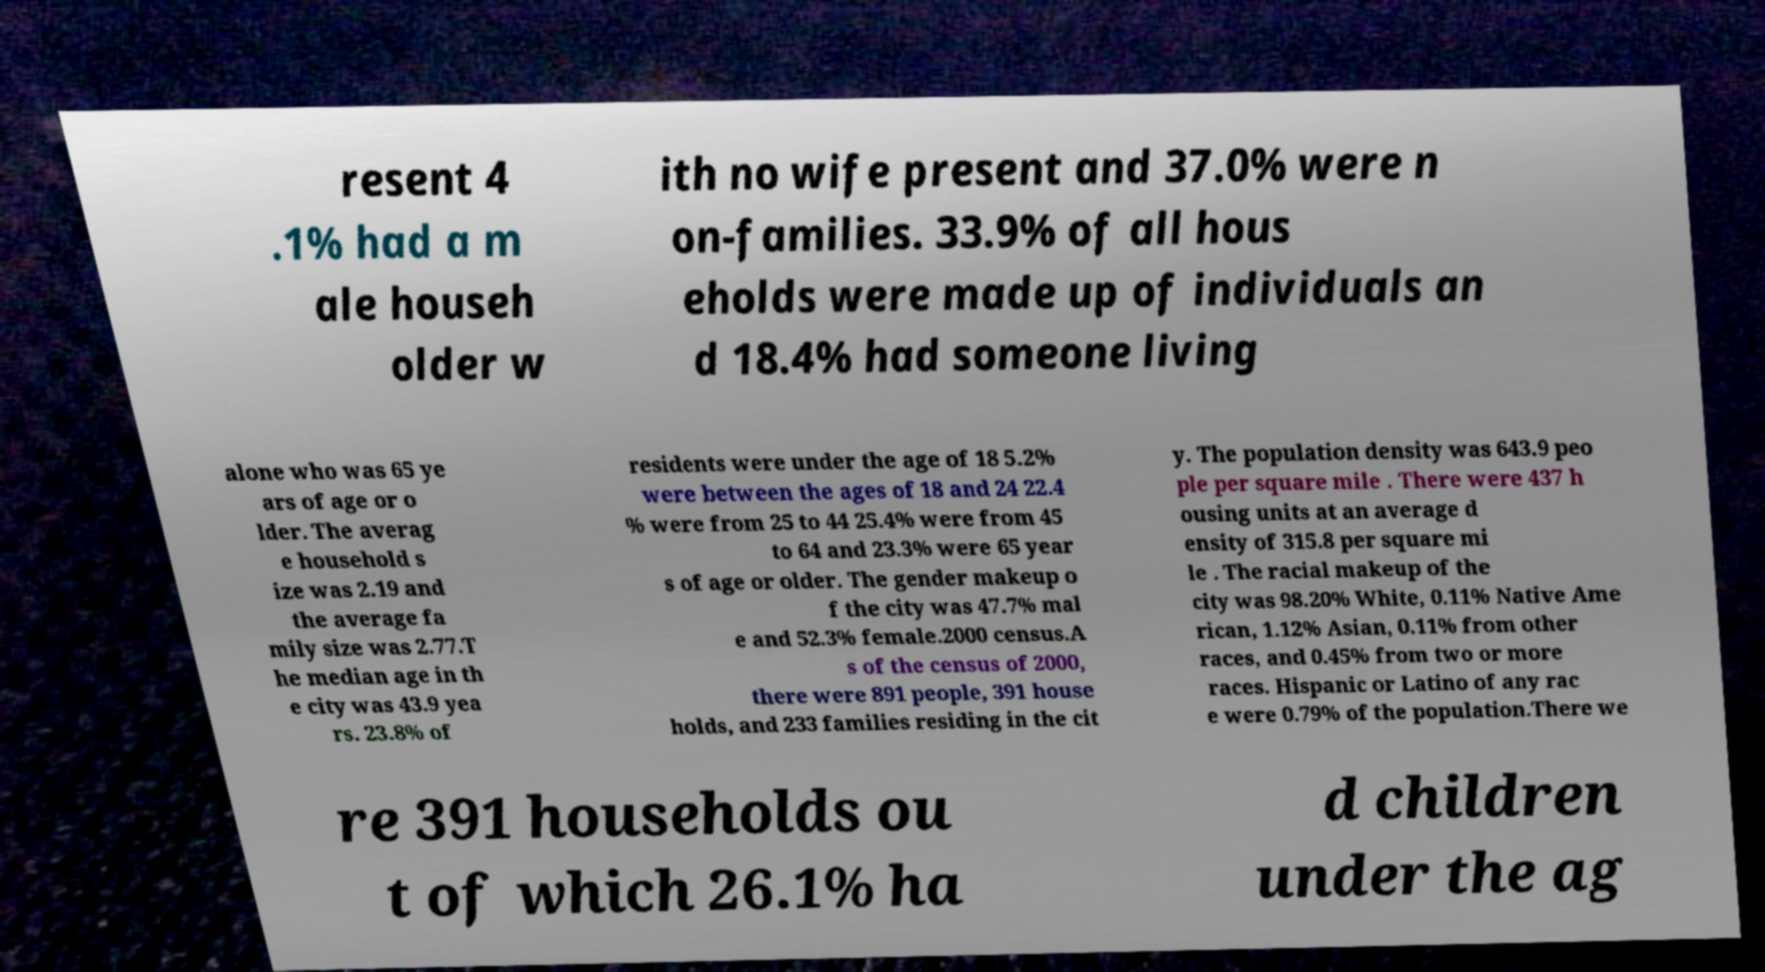I need the written content from this picture converted into text. Can you do that? resent 4 .1% had a m ale househ older w ith no wife present and 37.0% were n on-families. 33.9% of all hous eholds were made up of individuals an d 18.4% had someone living alone who was 65 ye ars of age or o lder. The averag e household s ize was 2.19 and the average fa mily size was 2.77.T he median age in th e city was 43.9 yea rs. 23.8% of residents were under the age of 18 5.2% were between the ages of 18 and 24 22.4 % were from 25 to 44 25.4% were from 45 to 64 and 23.3% were 65 year s of age or older. The gender makeup o f the city was 47.7% mal e and 52.3% female.2000 census.A s of the census of 2000, there were 891 people, 391 house holds, and 233 families residing in the cit y. The population density was 643.9 peo ple per square mile . There were 437 h ousing units at an average d ensity of 315.8 per square mi le . The racial makeup of the city was 98.20% White, 0.11% Native Ame rican, 1.12% Asian, 0.11% from other races, and 0.45% from two or more races. Hispanic or Latino of any rac e were 0.79% of the population.There we re 391 households ou t of which 26.1% ha d children under the ag 